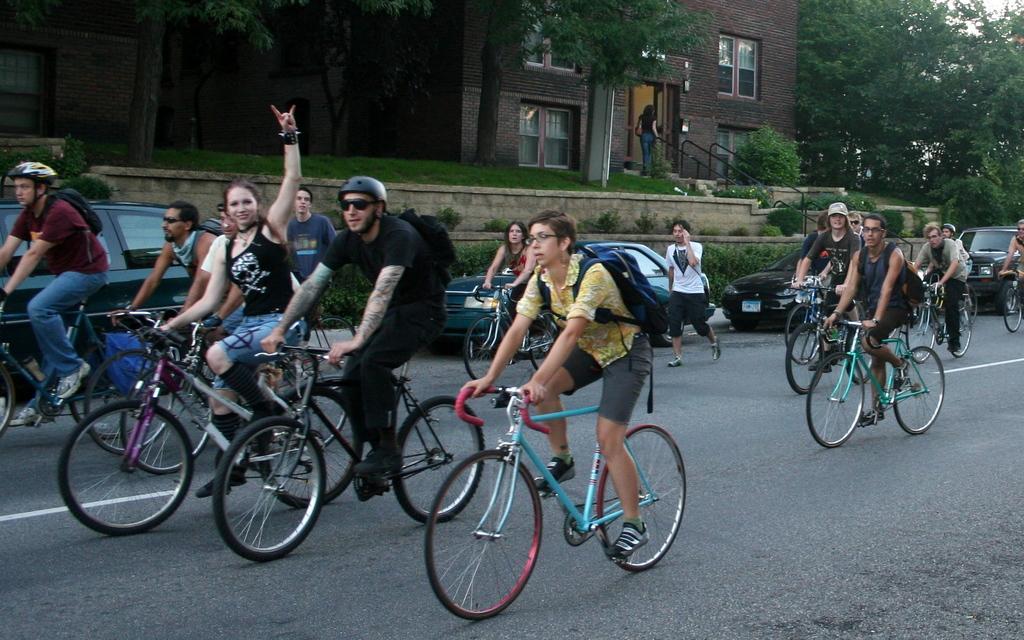Can you describe this image briefly? In this image we can see motor vehicles parked on the road, persons sitting on the bicycles, persons walking on the road, staircase, railings, buildings, windows, trees and sky. 